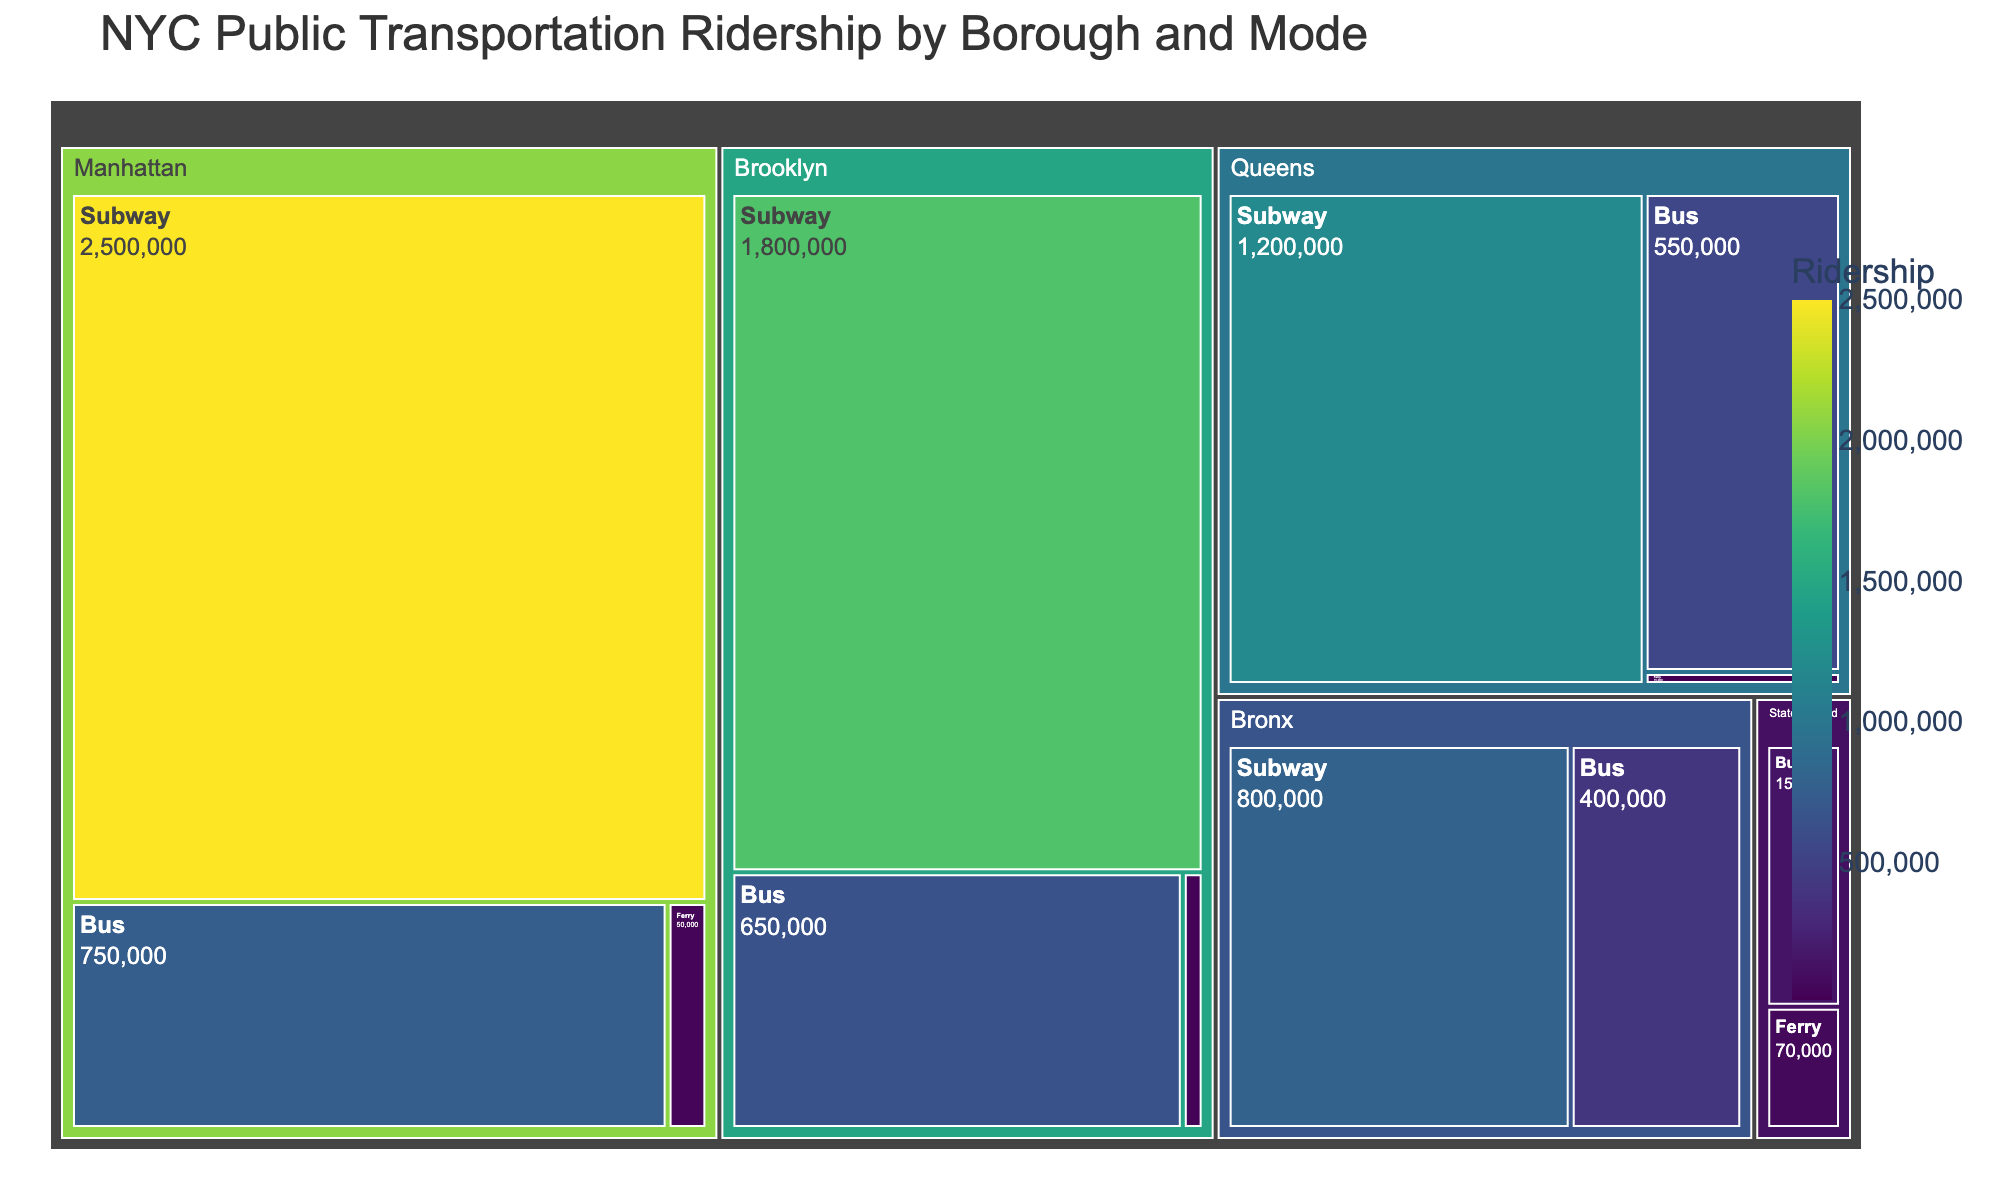How many boroughs are represented in the treemap? The treemap is divided into different sections based on the boroughs. Counting these sections will give the number of boroughs represented.
Answer: 5 What is the ridership of the subway in Manhattan? Locate the subway section within the Manhattan borough and note the ridership value displayed there.
Answer: 2,500,000 Which borough has the highest total ridership? Sum the ridership values for each borough and compare the totals. Manhattan is expected to have the highest because it has the highest values for both subway and bus ridership.
Answer: Manhattan What is the total ridership for buses across all boroughs combined? Add the bus ridership values for all the boroughs: 750,000 (Manhattan) + 650,000 (Brooklyn) + 550,000 (Queens) + 400,000 (Bronx) + 150,000 (Staten Island).
Answer: 2,500,000 Which mode of transportation has the lowest ridership in Brooklyn? Within the Brooklyn section, compare the values for subway, bus, and ferry. The ferry ridership is the lowest.
Answer: Ferry How does the ridership of subways in the Bronx compare to those in Queens? Compare the ridership values: Bronx (800,000) versus Queens (1,200,000). Queens has higher subway ridership.
Answer: Queens has higher subway ridership By how much does the bus ridership in Queens exceed that in Staten Island? Subtract the bus ridership in Staten Island (150,000) from the bus ridership in Queens (550,000).
Answer: 400,000 What is the total ridership for ferry transportation in all boroughs? Sum the ferry ridership values for each borough: 50,000 (Manhattan) + 30,000 (Brooklyn) + 15,000 (Queens) + 70,000 (Staten Island).
Answer: 165,000 Which mode of transportation across all boroughs has the highest ridership? Given the high values for subway ridership in Manhattan, Brooklyn, Queens, and Bronx, add these values. The subway will have the highest total ridership among all modes.
Answer: Subway Which borough has the smallest combined ridership for all modes? Calculate the total ridership for each borough and identify the smallest sum. Staten Island will have the smallest combined ridership since its individual values are much lower compared to others.
Answer: Staten Island 